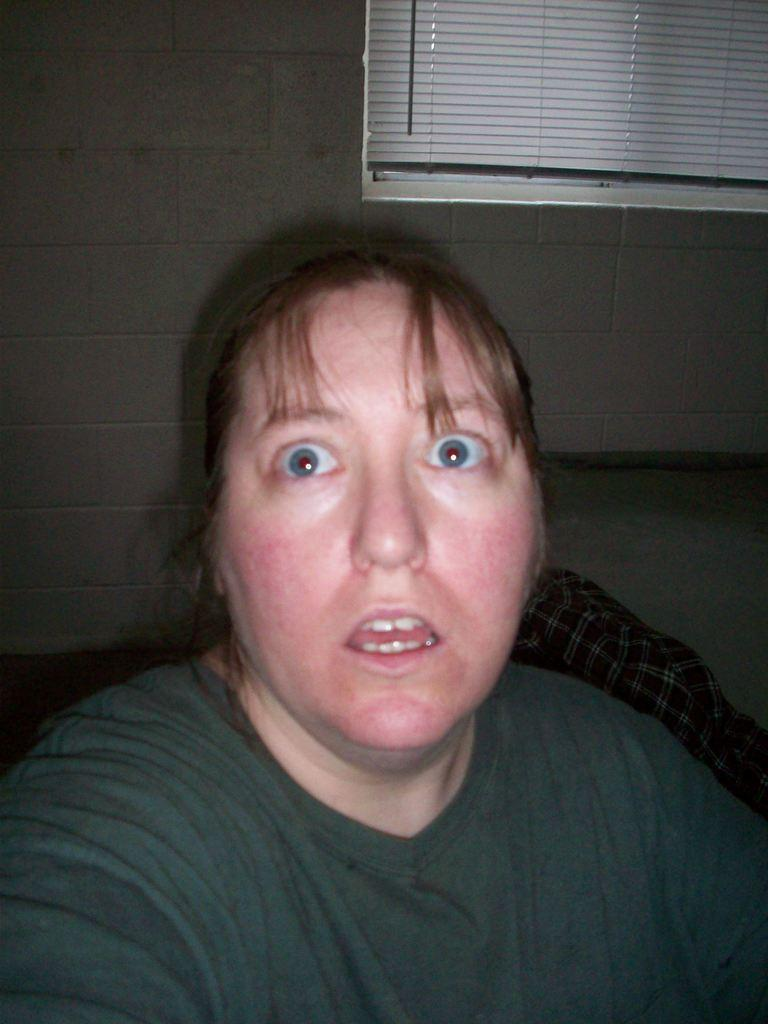Who is present in the image? There is a woman in the image. What is behind the woman in the image? There is a wall behind the woman. What can be seen on the wall in the image? Window blinds are visible in the image. How many spiders are crawling on the woman's shoulder in the image? There are no spiders visible in the image; the image only shows a woman, a wall, and window blinds. 